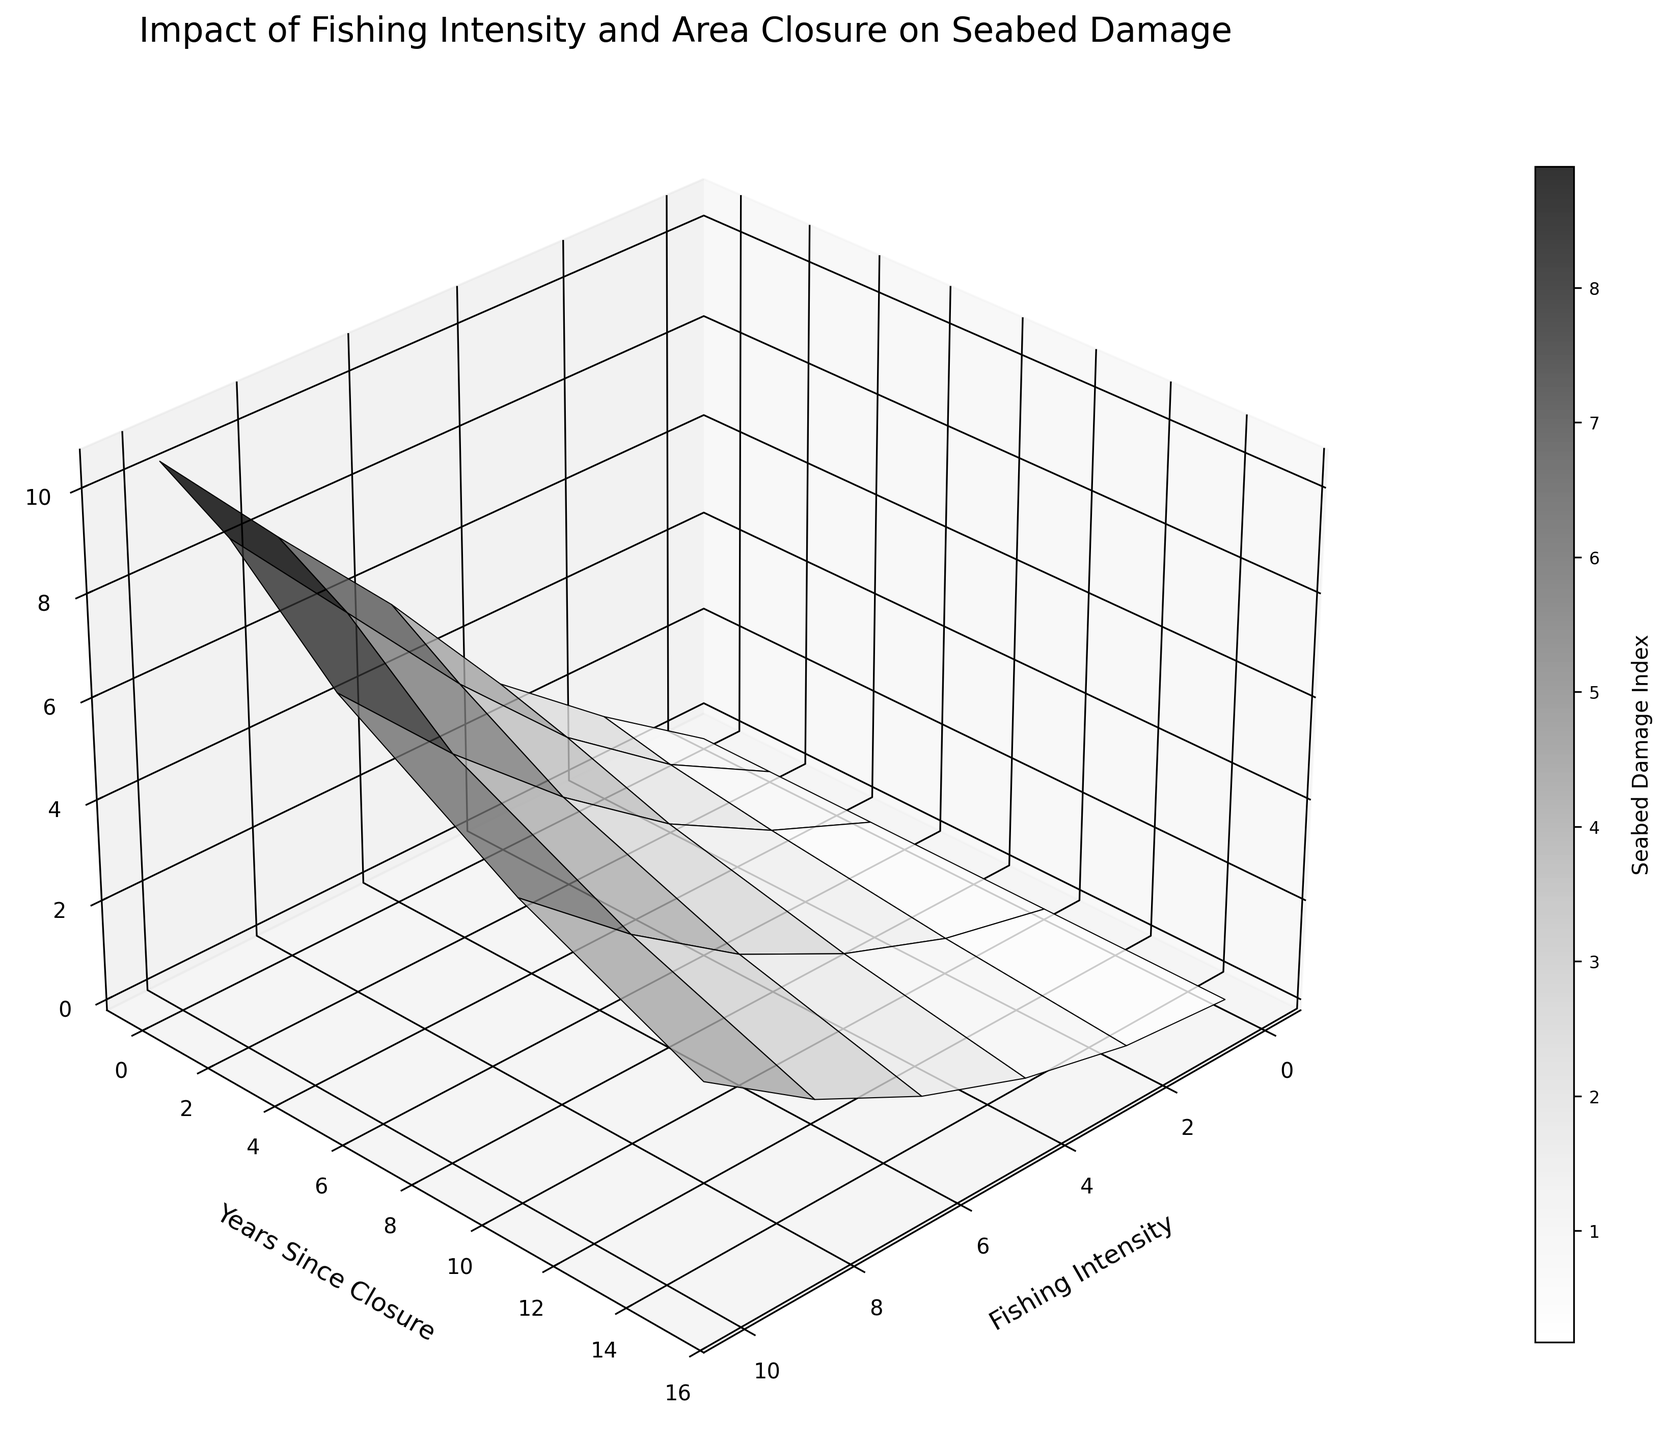What are the axes labels of the plot? The labels for the x, y, and z-axes are "Fishing Intensity," "Years Since Closure," and "Seabed Damage Index," respectively. These labels are located next to each axis in the plot.
Answer: Fishing Intensity, Years Since Closure, Seabed Damage Index What does the highest point on the plot represent? The highest point on the plot indicates the maximum value of the Seabed Damage Index, which occurs when Fishing Intensity is highest and the area has experienced no closure (0 years since closure). This is visually identifiable as the peak of the surface.
Answer: Maximum Seabed Damage Index at highest Fishing Intensity and no closure How does the Seabed Damage Index change with increasing Fishing Intensity when the area has been closed for 10 years? For each level of Fishing Intensity on the x-axis, you can observe the corresponding Seabed Damage Index along the z-axis when Years_Since_Closure is 10. The Seabed Damage Index gradually increases as Fishing Intensity increases from 0 to 10, indicated by higher z-values moving along the x-axis for a fixed y=10.
Answer: Gradually increases What is the Seabed Damage Index when Fishing Intensity is 6 and the area has been closed for 5 years? Find the point where Fishing Intensity equals 6 and Years_Since_Closure equals 5 on the plot. Then, track this point to the corresponding value on the z-axis. The Seabed Damage Index value can be read directly from this intersection.
Answer: 3.7 Compare the Seabed Damage Index for areas closed for 2 years versus areas closed for 15 years at a Fishing Intensity of 8. At a Fishing Intensity of 8, compare the Seabed Damage Index values for the points corresponding to 2 years and 15 years since closure. These are visualized at the same x-coordinate but different y-coordinates on the plot and tracked to their respective z-values.
Answer: 7.3 (2 years), 2.6 (15 years) At what point does the Seabed Damage Index start below 1 when the area has been closed? Observe the plot and identify where the z-values are less than 1 on the surface. This examination shows that the corresponding x and y pairs (Fishing Intensity and Years_Since_Closure) match the condition.
Answer: Seabed Damage Index below 1 starts at Fishing Intensity 2 and Closure 10 years Which closure period shows the most significant reduction in Seabed Damage Index for a fixed Fishing Intensity of 10? Examine the plot along the y-axis for fixed Fishing Intensity (x=10) and observe the rate of decline along the z-axis for different y-values. This rate shows the most steep reduction over certain years.
Answer: 0 to 2 years How does the color change on the surface plot represent Seabed Damage Index values? The colors on the plot vary based on different Seabed Damage Index values and contribute to a visual gradient on the surface. Darker shades indicate lower values, while lighter shades indicate higher values of the Seabed Damage Index.
Answer: Darker for lower, lighter for higher Seabed Damage Index What is the trend of the Seabed Damage Index when years since closure increase from 0 to 15, given a Fishing Intensity of 6? Observe the plot along the y-axis for Fishing Intensity fixed at 6, noting how the z-value (Seabed Damage Index) changes. The trend shows a clear decline in Seabed Damage Index as the closure period increases.
Answer: Declining trend 